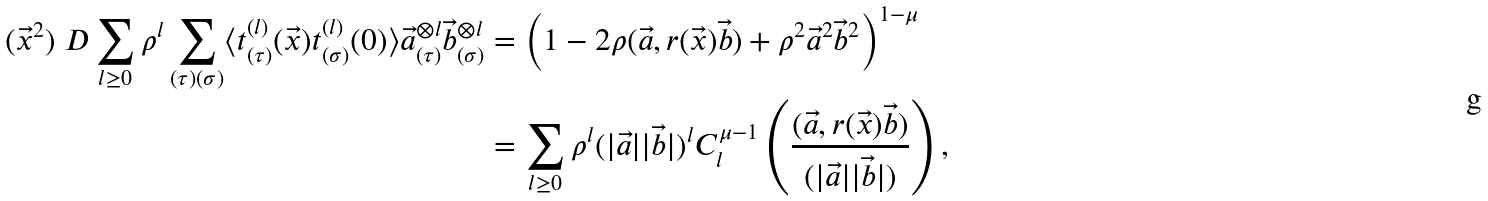<formula> <loc_0><loc_0><loc_500><loc_500>( \vec { x } ^ { 2 } ) ^ { \ } D \sum _ { l \geq 0 } \rho ^ { l } \sum _ { ( \tau ) ( \sigma ) } \langle t ^ { ( l ) } _ { ( \tau ) } ( \vec { x } ) t ^ { ( l ) } _ { ( \sigma ) } ( 0 ) \rangle \vec { a } ^ { \otimes l } _ { ( \tau ) } \vec { b } ^ { \otimes l } _ { ( \sigma ) } & = \left ( 1 - 2 \rho ( \vec { a } , r ( \vec { x } ) \vec { b } ) + \rho ^ { 2 } \vec { a } ^ { 2 } \vec { b } ^ { 2 } \right ) ^ { 1 - \mu } \\ & = \sum _ { l \geq 0 } \rho ^ { l } ( | \vec { a } | | \vec { b } | ) ^ { l } C _ { l } ^ { \mu - 1 } \left ( \frac { ( \vec { a } , r ( \vec { x } ) \vec { b } ) } { ( | \vec { a } | | \vec { b } | ) } \right ) ,</formula> 